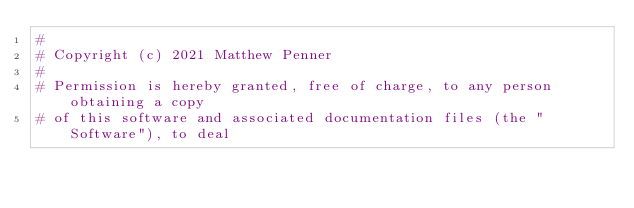<code> <loc_0><loc_0><loc_500><loc_500><_Dockerfile_>#
# Copyright (c) 2021 Matthew Penner
#
# Permission is hereby granted, free of charge, to any person obtaining a copy
# of this software and associated documentation files (the "Software"), to deal</code> 